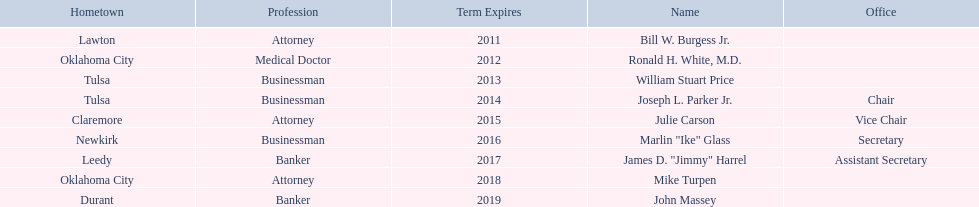Which state regent is from the same hometown as ronald h. white, m.d.? Mike Turpen. 